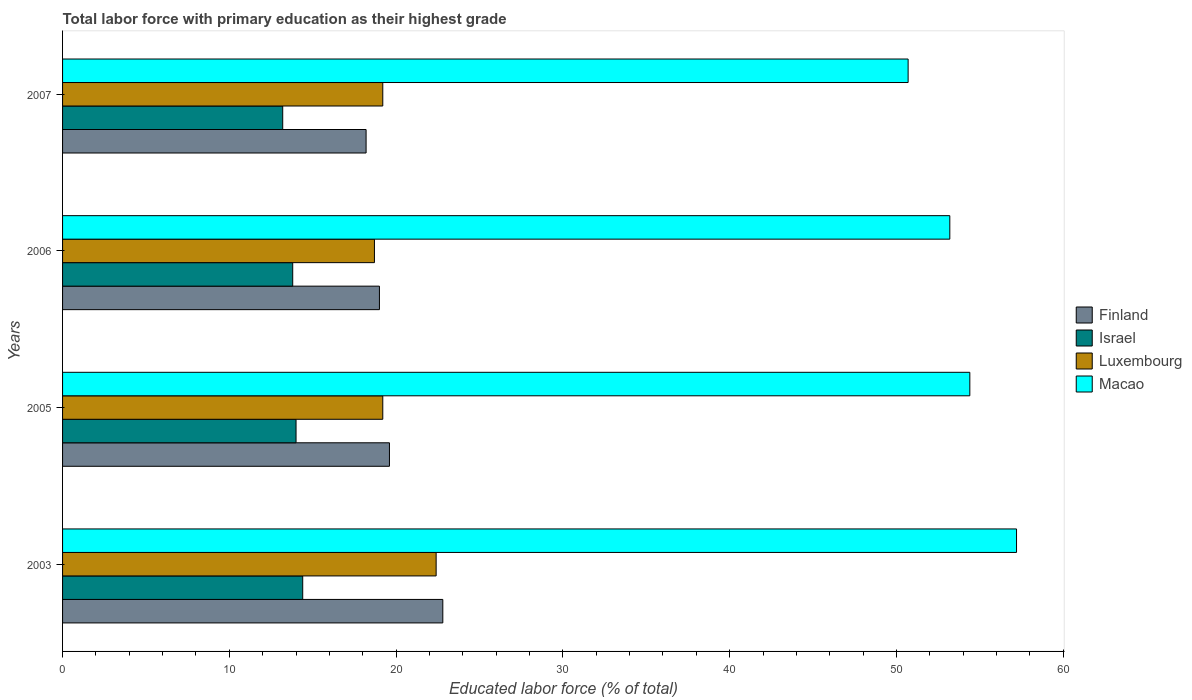How many groups of bars are there?
Offer a terse response. 4. Are the number of bars on each tick of the Y-axis equal?
Your answer should be very brief. Yes. How many bars are there on the 1st tick from the top?
Provide a short and direct response. 4. How many bars are there on the 3rd tick from the bottom?
Provide a short and direct response. 4. What is the label of the 4th group of bars from the top?
Give a very brief answer. 2003. What is the percentage of total labor force with primary education in Israel in 2003?
Your answer should be very brief. 14.4. Across all years, what is the maximum percentage of total labor force with primary education in Macao?
Offer a very short reply. 57.2. Across all years, what is the minimum percentage of total labor force with primary education in Luxembourg?
Your answer should be compact. 18.7. In which year was the percentage of total labor force with primary education in Macao minimum?
Your answer should be very brief. 2007. What is the total percentage of total labor force with primary education in Israel in the graph?
Ensure brevity in your answer.  55.4. What is the difference between the percentage of total labor force with primary education in Luxembourg in 2003 and that in 2005?
Your response must be concise. 3.2. What is the difference between the percentage of total labor force with primary education in Luxembourg in 2007 and the percentage of total labor force with primary education in Finland in 2003?
Provide a succinct answer. -3.6. What is the average percentage of total labor force with primary education in Israel per year?
Your response must be concise. 13.85. In the year 2007, what is the difference between the percentage of total labor force with primary education in Israel and percentage of total labor force with primary education in Finland?
Make the answer very short. -5. In how many years, is the percentage of total labor force with primary education in Israel greater than 36 %?
Provide a short and direct response. 0. What is the ratio of the percentage of total labor force with primary education in Israel in 2005 to that in 2006?
Your answer should be very brief. 1.01. Is the percentage of total labor force with primary education in Israel in 2005 less than that in 2007?
Give a very brief answer. No. What is the difference between the highest and the second highest percentage of total labor force with primary education in Finland?
Offer a terse response. 3.2. What is the difference between the highest and the lowest percentage of total labor force with primary education in Luxembourg?
Give a very brief answer. 3.7. In how many years, is the percentage of total labor force with primary education in Luxembourg greater than the average percentage of total labor force with primary education in Luxembourg taken over all years?
Make the answer very short. 1. Is the sum of the percentage of total labor force with primary education in Finland in 2003 and 2005 greater than the maximum percentage of total labor force with primary education in Macao across all years?
Give a very brief answer. No. Is it the case that in every year, the sum of the percentage of total labor force with primary education in Finland and percentage of total labor force with primary education in Macao is greater than the sum of percentage of total labor force with primary education in Luxembourg and percentage of total labor force with primary education in Israel?
Offer a terse response. Yes. What does the 4th bar from the bottom in 2005 represents?
Ensure brevity in your answer.  Macao. How many years are there in the graph?
Offer a very short reply. 4. Does the graph contain grids?
Provide a succinct answer. No. How are the legend labels stacked?
Offer a very short reply. Vertical. What is the title of the graph?
Make the answer very short. Total labor force with primary education as their highest grade. Does "Niger" appear as one of the legend labels in the graph?
Your response must be concise. No. What is the label or title of the X-axis?
Offer a very short reply. Educated labor force (% of total). What is the label or title of the Y-axis?
Make the answer very short. Years. What is the Educated labor force (% of total) in Finland in 2003?
Give a very brief answer. 22.8. What is the Educated labor force (% of total) in Israel in 2003?
Provide a short and direct response. 14.4. What is the Educated labor force (% of total) in Luxembourg in 2003?
Offer a terse response. 22.4. What is the Educated labor force (% of total) in Macao in 2003?
Ensure brevity in your answer.  57.2. What is the Educated labor force (% of total) of Finland in 2005?
Ensure brevity in your answer.  19.6. What is the Educated labor force (% of total) in Luxembourg in 2005?
Ensure brevity in your answer.  19.2. What is the Educated labor force (% of total) in Macao in 2005?
Ensure brevity in your answer.  54.4. What is the Educated labor force (% of total) of Israel in 2006?
Provide a succinct answer. 13.8. What is the Educated labor force (% of total) in Luxembourg in 2006?
Give a very brief answer. 18.7. What is the Educated labor force (% of total) in Macao in 2006?
Provide a short and direct response. 53.2. What is the Educated labor force (% of total) of Finland in 2007?
Your answer should be very brief. 18.2. What is the Educated labor force (% of total) of Israel in 2007?
Keep it short and to the point. 13.2. What is the Educated labor force (% of total) of Luxembourg in 2007?
Offer a very short reply. 19.2. What is the Educated labor force (% of total) of Macao in 2007?
Offer a terse response. 50.7. Across all years, what is the maximum Educated labor force (% of total) of Finland?
Your answer should be compact. 22.8. Across all years, what is the maximum Educated labor force (% of total) of Israel?
Make the answer very short. 14.4. Across all years, what is the maximum Educated labor force (% of total) in Luxembourg?
Your response must be concise. 22.4. Across all years, what is the maximum Educated labor force (% of total) in Macao?
Provide a succinct answer. 57.2. Across all years, what is the minimum Educated labor force (% of total) of Finland?
Offer a terse response. 18.2. Across all years, what is the minimum Educated labor force (% of total) in Israel?
Provide a succinct answer. 13.2. Across all years, what is the minimum Educated labor force (% of total) of Luxembourg?
Give a very brief answer. 18.7. Across all years, what is the minimum Educated labor force (% of total) in Macao?
Provide a short and direct response. 50.7. What is the total Educated labor force (% of total) in Finland in the graph?
Your answer should be compact. 79.6. What is the total Educated labor force (% of total) in Israel in the graph?
Offer a terse response. 55.4. What is the total Educated labor force (% of total) in Luxembourg in the graph?
Provide a short and direct response. 79.5. What is the total Educated labor force (% of total) of Macao in the graph?
Offer a very short reply. 215.5. What is the difference between the Educated labor force (% of total) of Finland in 2003 and that in 2005?
Give a very brief answer. 3.2. What is the difference between the Educated labor force (% of total) of Macao in 2003 and that in 2006?
Your answer should be very brief. 4. What is the difference between the Educated labor force (% of total) of Finland in 2003 and that in 2007?
Provide a succinct answer. 4.6. What is the difference between the Educated labor force (% of total) in Luxembourg in 2005 and that in 2006?
Give a very brief answer. 0.5. What is the difference between the Educated labor force (% of total) of Macao in 2005 and that in 2006?
Ensure brevity in your answer.  1.2. What is the difference between the Educated labor force (% of total) in Israel in 2005 and that in 2007?
Your answer should be compact. 0.8. What is the difference between the Educated labor force (% of total) of Macao in 2006 and that in 2007?
Provide a short and direct response. 2.5. What is the difference between the Educated labor force (% of total) of Finland in 2003 and the Educated labor force (% of total) of Macao in 2005?
Your answer should be very brief. -31.6. What is the difference between the Educated labor force (% of total) in Luxembourg in 2003 and the Educated labor force (% of total) in Macao in 2005?
Keep it short and to the point. -32. What is the difference between the Educated labor force (% of total) in Finland in 2003 and the Educated labor force (% of total) in Israel in 2006?
Ensure brevity in your answer.  9. What is the difference between the Educated labor force (% of total) of Finland in 2003 and the Educated labor force (% of total) of Macao in 2006?
Your answer should be very brief. -30.4. What is the difference between the Educated labor force (% of total) of Israel in 2003 and the Educated labor force (% of total) of Macao in 2006?
Provide a succinct answer. -38.8. What is the difference between the Educated labor force (% of total) of Luxembourg in 2003 and the Educated labor force (% of total) of Macao in 2006?
Your answer should be compact. -30.8. What is the difference between the Educated labor force (% of total) of Finland in 2003 and the Educated labor force (% of total) of Israel in 2007?
Make the answer very short. 9.6. What is the difference between the Educated labor force (% of total) in Finland in 2003 and the Educated labor force (% of total) in Macao in 2007?
Ensure brevity in your answer.  -27.9. What is the difference between the Educated labor force (% of total) of Israel in 2003 and the Educated labor force (% of total) of Macao in 2007?
Ensure brevity in your answer.  -36.3. What is the difference between the Educated labor force (% of total) of Luxembourg in 2003 and the Educated labor force (% of total) of Macao in 2007?
Offer a terse response. -28.3. What is the difference between the Educated labor force (% of total) in Finland in 2005 and the Educated labor force (% of total) in Luxembourg in 2006?
Your answer should be very brief. 0.9. What is the difference between the Educated labor force (% of total) of Finland in 2005 and the Educated labor force (% of total) of Macao in 2006?
Offer a terse response. -33.6. What is the difference between the Educated labor force (% of total) in Israel in 2005 and the Educated labor force (% of total) in Macao in 2006?
Make the answer very short. -39.2. What is the difference between the Educated labor force (% of total) of Luxembourg in 2005 and the Educated labor force (% of total) of Macao in 2006?
Give a very brief answer. -34. What is the difference between the Educated labor force (% of total) of Finland in 2005 and the Educated labor force (% of total) of Israel in 2007?
Keep it short and to the point. 6.4. What is the difference between the Educated labor force (% of total) of Finland in 2005 and the Educated labor force (% of total) of Macao in 2007?
Provide a succinct answer. -31.1. What is the difference between the Educated labor force (% of total) in Israel in 2005 and the Educated labor force (% of total) in Macao in 2007?
Your answer should be compact. -36.7. What is the difference between the Educated labor force (% of total) of Luxembourg in 2005 and the Educated labor force (% of total) of Macao in 2007?
Your answer should be compact. -31.5. What is the difference between the Educated labor force (% of total) in Finland in 2006 and the Educated labor force (% of total) in Israel in 2007?
Your answer should be very brief. 5.8. What is the difference between the Educated labor force (% of total) of Finland in 2006 and the Educated labor force (% of total) of Luxembourg in 2007?
Your response must be concise. -0.2. What is the difference between the Educated labor force (% of total) of Finland in 2006 and the Educated labor force (% of total) of Macao in 2007?
Your answer should be compact. -31.7. What is the difference between the Educated labor force (% of total) in Israel in 2006 and the Educated labor force (% of total) in Luxembourg in 2007?
Make the answer very short. -5.4. What is the difference between the Educated labor force (% of total) of Israel in 2006 and the Educated labor force (% of total) of Macao in 2007?
Offer a terse response. -36.9. What is the difference between the Educated labor force (% of total) in Luxembourg in 2006 and the Educated labor force (% of total) in Macao in 2007?
Your answer should be compact. -32. What is the average Educated labor force (% of total) of Finland per year?
Keep it short and to the point. 19.9. What is the average Educated labor force (% of total) in Israel per year?
Offer a terse response. 13.85. What is the average Educated labor force (% of total) in Luxembourg per year?
Provide a succinct answer. 19.88. What is the average Educated labor force (% of total) in Macao per year?
Your response must be concise. 53.88. In the year 2003, what is the difference between the Educated labor force (% of total) of Finland and Educated labor force (% of total) of Macao?
Give a very brief answer. -34.4. In the year 2003, what is the difference between the Educated labor force (% of total) in Israel and Educated labor force (% of total) in Macao?
Offer a terse response. -42.8. In the year 2003, what is the difference between the Educated labor force (% of total) of Luxembourg and Educated labor force (% of total) of Macao?
Offer a terse response. -34.8. In the year 2005, what is the difference between the Educated labor force (% of total) of Finland and Educated labor force (% of total) of Macao?
Keep it short and to the point. -34.8. In the year 2005, what is the difference between the Educated labor force (% of total) of Israel and Educated labor force (% of total) of Luxembourg?
Provide a short and direct response. -5.2. In the year 2005, what is the difference between the Educated labor force (% of total) in Israel and Educated labor force (% of total) in Macao?
Keep it short and to the point. -40.4. In the year 2005, what is the difference between the Educated labor force (% of total) of Luxembourg and Educated labor force (% of total) of Macao?
Offer a very short reply. -35.2. In the year 2006, what is the difference between the Educated labor force (% of total) in Finland and Educated labor force (% of total) in Israel?
Provide a succinct answer. 5.2. In the year 2006, what is the difference between the Educated labor force (% of total) of Finland and Educated labor force (% of total) of Luxembourg?
Offer a very short reply. 0.3. In the year 2006, what is the difference between the Educated labor force (% of total) of Finland and Educated labor force (% of total) of Macao?
Ensure brevity in your answer.  -34.2. In the year 2006, what is the difference between the Educated labor force (% of total) in Israel and Educated labor force (% of total) in Macao?
Your response must be concise. -39.4. In the year 2006, what is the difference between the Educated labor force (% of total) of Luxembourg and Educated labor force (% of total) of Macao?
Provide a succinct answer. -34.5. In the year 2007, what is the difference between the Educated labor force (% of total) in Finland and Educated labor force (% of total) in Macao?
Provide a succinct answer. -32.5. In the year 2007, what is the difference between the Educated labor force (% of total) in Israel and Educated labor force (% of total) in Macao?
Your answer should be very brief. -37.5. In the year 2007, what is the difference between the Educated labor force (% of total) in Luxembourg and Educated labor force (% of total) in Macao?
Keep it short and to the point. -31.5. What is the ratio of the Educated labor force (% of total) in Finland in 2003 to that in 2005?
Keep it short and to the point. 1.16. What is the ratio of the Educated labor force (% of total) in Israel in 2003 to that in 2005?
Provide a short and direct response. 1.03. What is the ratio of the Educated labor force (% of total) in Luxembourg in 2003 to that in 2005?
Your answer should be very brief. 1.17. What is the ratio of the Educated labor force (% of total) in Macao in 2003 to that in 2005?
Ensure brevity in your answer.  1.05. What is the ratio of the Educated labor force (% of total) of Israel in 2003 to that in 2006?
Offer a terse response. 1.04. What is the ratio of the Educated labor force (% of total) in Luxembourg in 2003 to that in 2006?
Give a very brief answer. 1.2. What is the ratio of the Educated labor force (% of total) of Macao in 2003 to that in 2006?
Offer a very short reply. 1.08. What is the ratio of the Educated labor force (% of total) in Finland in 2003 to that in 2007?
Make the answer very short. 1.25. What is the ratio of the Educated labor force (% of total) of Israel in 2003 to that in 2007?
Your answer should be very brief. 1.09. What is the ratio of the Educated labor force (% of total) of Luxembourg in 2003 to that in 2007?
Offer a very short reply. 1.17. What is the ratio of the Educated labor force (% of total) in Macao in 2003 to that in 2007?
Your answer should be compact. 1.13. What is the ratio of the Educated labor force (% of total) in Finland in 2005 to that in 2006?
Make the answer very short. 1.03. What is the ratio of the Educated labor force (% of total) in Israel in 2005 to that in 2006?
Give a very brief answer. 1.01. What is the ratio of the Educated labor force (% of total) of Luxembourg in 2005 to that in 2006?
Your answer should be compact. 1.03. What is the ratio of the Educated labor force (% of total) in Macao in 2005 to that in 2006?
Give a very brief answer. 1.02. What is the ratio of the Educated labor force (% of total) of Finland in 2005 to that in 2007?
Ensure brevity in your answer.  1.08. What is the ratio of the Educated labor force (% of total) of Israel in 2005 to that in 2007?
Offer a very short reply. 1.06. What is the ratio of the Educated labor force (% of total) in Macao in 2005 to that in 2007?
Your answer should be very brief. 1.07. What is the ratio of the Educated labor force (% of total) of Finland in 2006 to that in 2007?
Give a very brief answer. 1.04. What is the ratio of the Educated labor force (% of total) of Israel in 2006 to that in 2007?
Provide a short and direct response. 1.05. What is the ratio of the Educated labor force (% of total) in Macao in 2006 to that in 2007?
Keep it short and to the point. 1.05. What is the difference between the highest and the second highest Educated labor force (% of total) of Luxembourg?
Make the answer very short. 3.2. What is the difference between the highest and the lowest Educated labor force (% of total) in Finland?
Provide a succinct answer. 4.6. What is the difference between the highest and the lowest Educated labor force (% of total) of Macao?
Give a very brief answer. 6.5. 